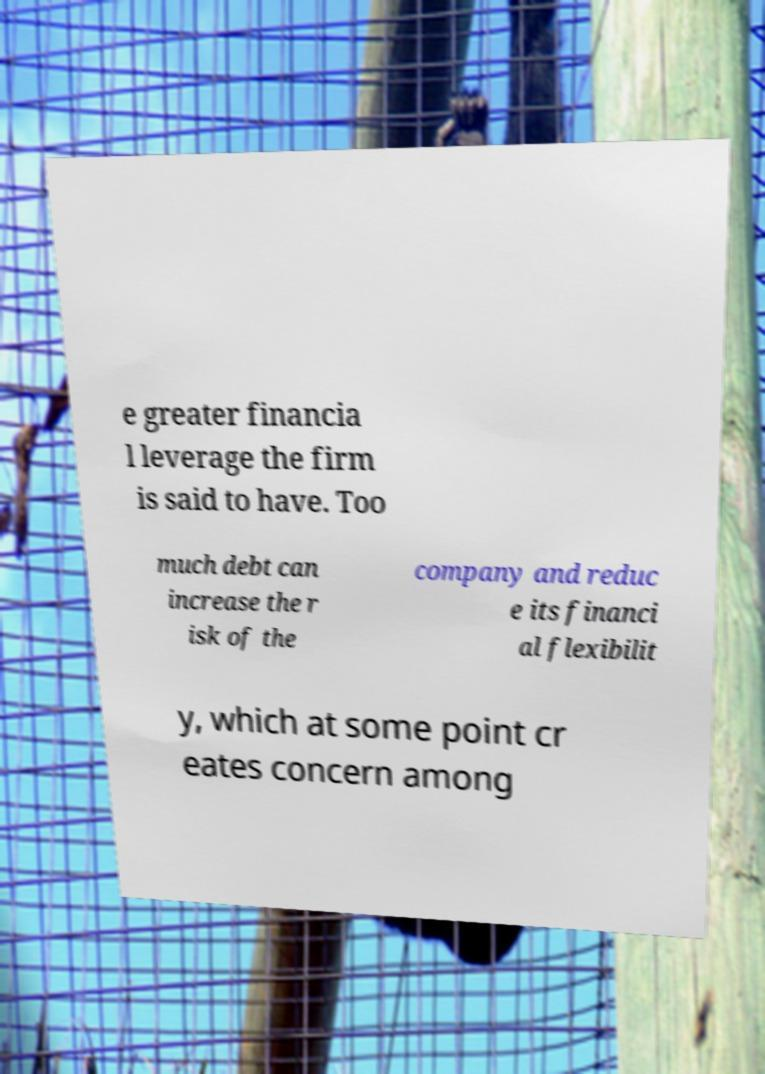For documentation purposes, I need the text within this image transcribed. Could you provide that? e greater financia l leverage the firm is said to have. Too much debt can increase the r isk of the company and reduc e its financi al flexibilit y, which at some point cr eates concern among 